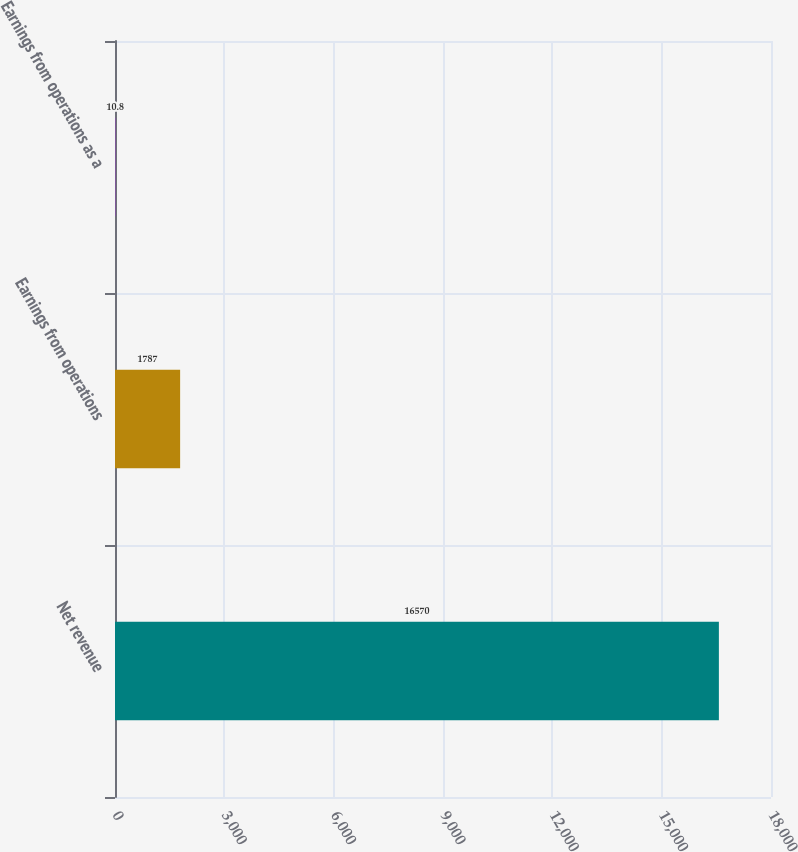Convert chart to OTSL. <chart><loc_0><loc_0><loc_500><loc_500><bar_chart><fcel>Net revenue<fcel>Earnings from operations<fcel>Earnings from operations as a<nl><fcel>16570<fcel>1787<fcel>10.8<nl></chart> 